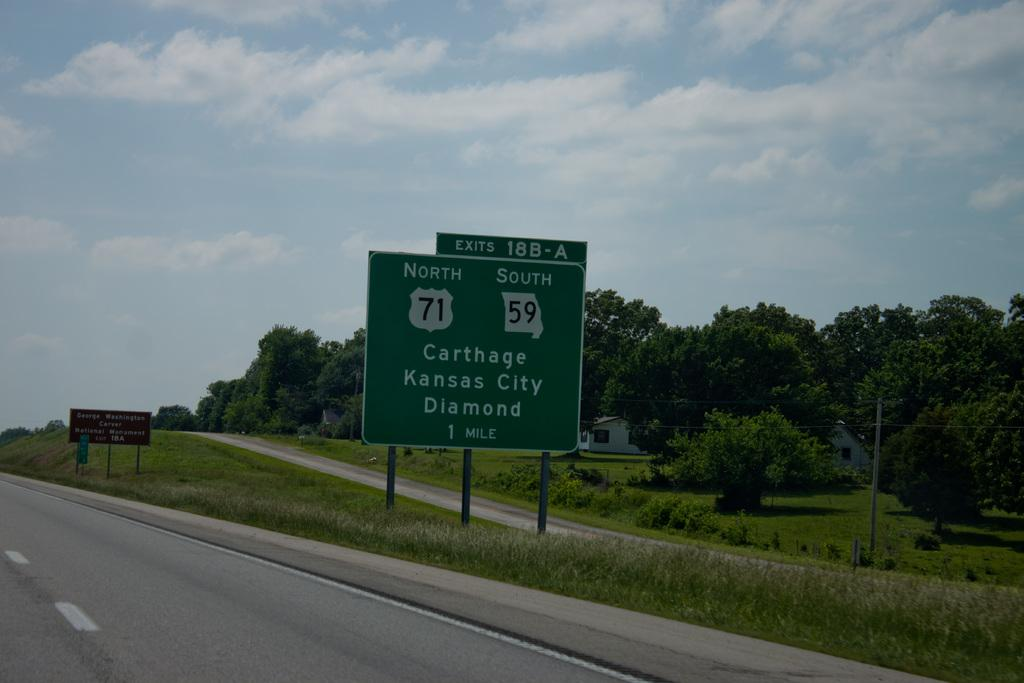<image>
Describe the image concisely. A large road sign indicates that Kansas City is one mile away. 